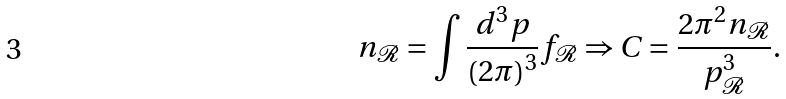Convert formula to latex. <formula><loc_0><loc_0><loc_500><loc_500>n _ { \mathcal { R } } = \int \frac { d ^ { 3 } p } { \left ( 2 \pi \right ) ^ { 3 } } f _ { \mathcal { R } } \Rightarrow C = \frac { 2 \pi ^ { 2 } n _ { \mathcal { R } } } { p _ { \mathcal { R } } ^ { 3 } } \text {.}</formula> 